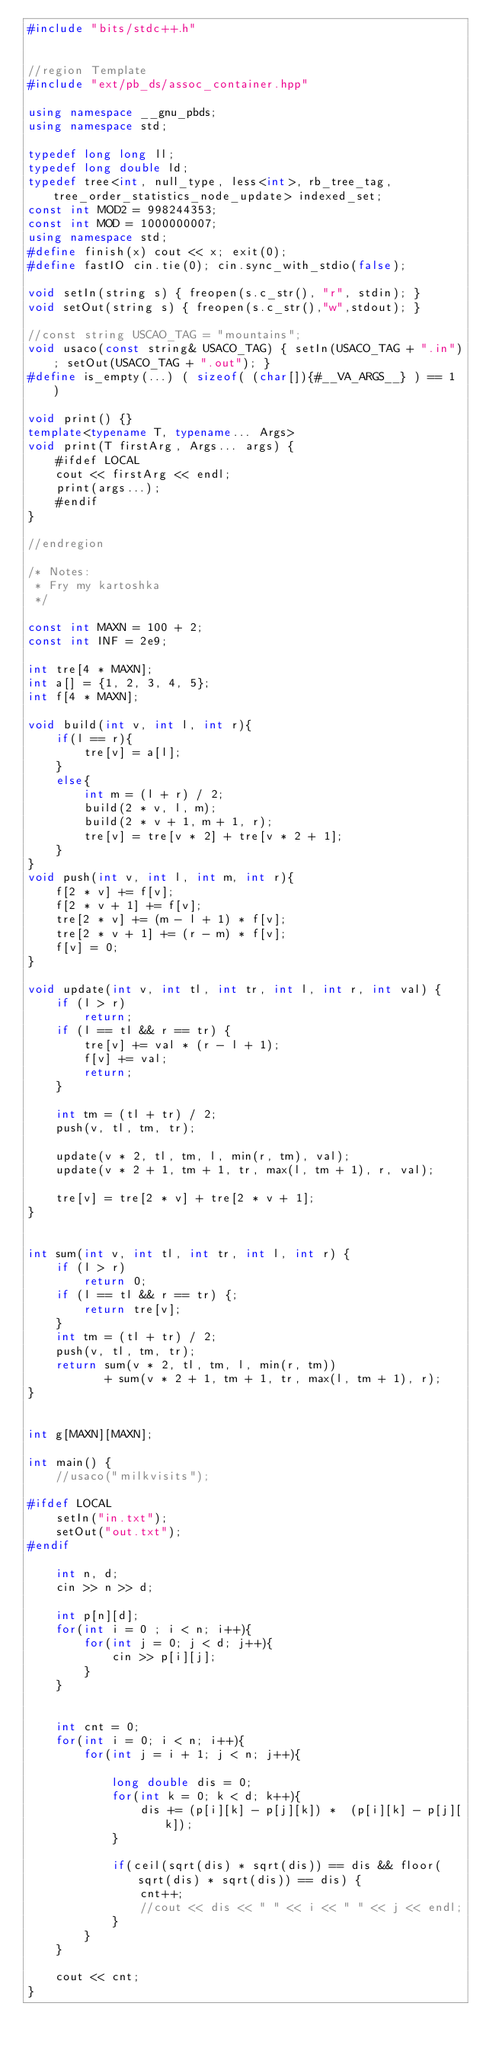<code> <loc_0><loc_0><loc_500><loc_500><_C++_>#include "bits/stdc++.h"


//region Template
#include "ext/pb_ds/assoc_container.hpp"

using namespace __gnu_pbds;
using namespace std;

typedef long long ll;
typedef long double ld;
typedef tree<int, null_type, less<int>, rb_tree_tag, tree_order_statistics_node_update> indexed_set;
const int MOD2 = 998244353;
const int MOD = 1000000007;
using namespace std;
#define finish(x) cout << x; exit(0);
#define fastIO cin.tie(0); cin.sync_with_stdio(false);

void setIn(string s) { freopen(s.c_str(), "r", stdin); }
void setOut(string s) { freopen(s.c_str(),"w",stdout); }

//const string USCAO_TAG = "mountains";
void usaco(const string& USACO_TAG) { setIn(USACO_TAG + ".in"); setOut(USACO_TAG + ".out"); }
#define is_empty(...) ( sizeof( (char[]){#__VA_ARGS__} ) == 1 )

void print() {}
template<typename T, typename... Args>
void print(T firstArg, Args... args) {
	#ifdef LOCAL
	cout << firstArg << endl;
	print(args...);
	#endif
}

//endregion

/* Notes:
 * Fry my kartoshka
 */

const int MAXN = 100 + 2;
const int INF = 2e9;

int tre[4 * MAXN];
int a[] = {1, 2, 3, 4, 5};
int f[4 * MAXN];

void build(int v, int l, int r){
	if(l == r){
		tre[v] = a[l];
	}
	else{
		int m = (l + r) / 2;
		build(2 * v, l, m);
		build(2 * v + 1, m + 1, r);
		tre[v] = tre[v * 2] + tre[v * 2 + 1];
	}
}
void push(int v, int l, int m, int r){
	f[2 * v] += f[v];
	f[2 * v + 1] += f[v];
	tre[2 * v] += (m - l + 1) * f[v];
	tre[2 * v + 1] += (r - m) * f[v];
	f[v] = 0;
}

void update(int v, int tl, int tr, int l, int r, int val) {
	if (l > r)
		return;
	if (l == tl && r == tr) {
		tre[v] += val * (r - l + 1);
		f[v] += val;
		return;
	}

	int tm = (tl + tr) / 2;
	push(v, tl, tm, tr);

	update(v * 2, tl, tm, l, min(r, tm), val);
	update(v * 2 + 1, tm + 1, tr, max(l, tm + 1), r, val);

	tre[v] = tre[2 * v] + tre[2 * v + 1];
}


int sum(int v, int tl, int tr, int l, int r) {
	if (l > r)
		return 0;
	if (l == tl && r == tr) {;
		return tre[v];
	}
	int tm = (tl + tr) / 2;
	push(v, tl, tm, tr);
	return sum(v * 2, tl, tm, l, min(r, tm))
		   + sum(v * 2 + 1, tm + 1, tr, max(l, tm + 1), r);
}


int g[MAXN][MAXN];

int main() {
	//usaco("milkvisits");

#ifdef LOCAL
	setIn("in.txt");
	setOut("out.txt");
#endif

	int n, d;
	cin >> n >> d;

	int p[n][d];
	for(int i = 0 ; i < n; i++){
		for(int j = 0; j < d; j++){
			cin >> p[i][j];
		}
	}


	int cnt = 0;
	for(int i = 0; i < n; i++){
		for(int j = i + 1; j < n; j++){

			long double dis = 0;
			for(int k = 0; k < d; k++){
				dis += (p[i][k] - p[j][k]) *  (p[i][k] - p[j][k]);
			}

			if(ceil(sqrt(dis) * sqrt(dis)) == dis && floor(sqrt(dis) * sqrt(dis)) == dis) {
				cnt++;
				//cout << dis << " " << i << " " << j << endl;
			}
		}
	}

	cout << cnt;
}</code> 